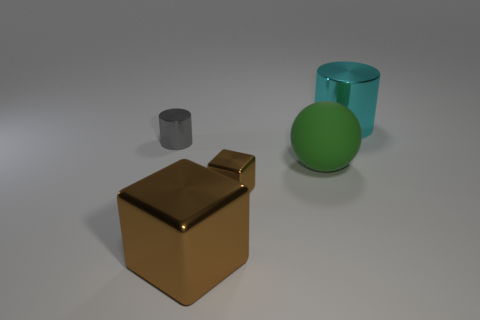Can you describe the lighting and shadows in the scene? The lighting in the image appears to be coming from the upper left side, casting soft shadows to the lower right of the objects, suggesting a diffuse light source. How does the lighting affect the appearance of the objects? The diffuse light creates soft shadows and subtle highlights, giving the objects a three-dimensional look and enhancing their colors and textures. 